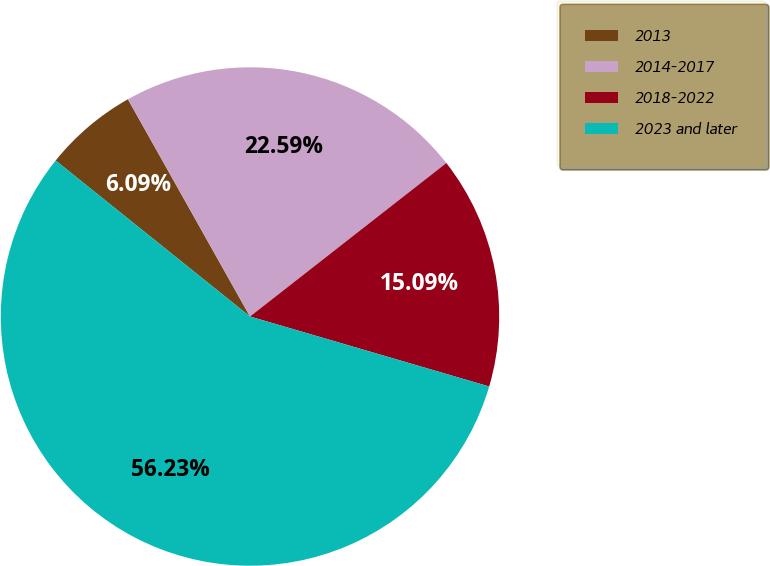<chart> <loc_0><loc_0><loc_500><loc_500><pie_chart><fcel>2013<fcel>2014-2017<fcel>2018-2022<fcel>2023 and later<nl><fcel>6.09%<fcel>22.59%<fcel>15.09%<fcel>56.24%<nl></chart> 